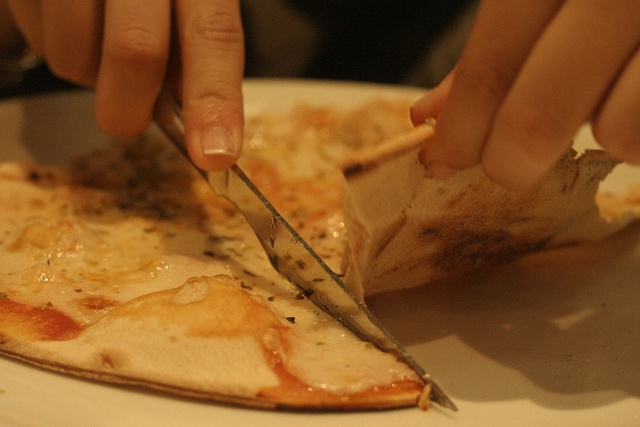Describe the objects in this image and their specific colors. I can see pizza in maroon, red, and orange tones, people in maroon and brown tones, pizza in maroon, brown, and orange tones, and knife in maroon, olive, and black tones in this image. 